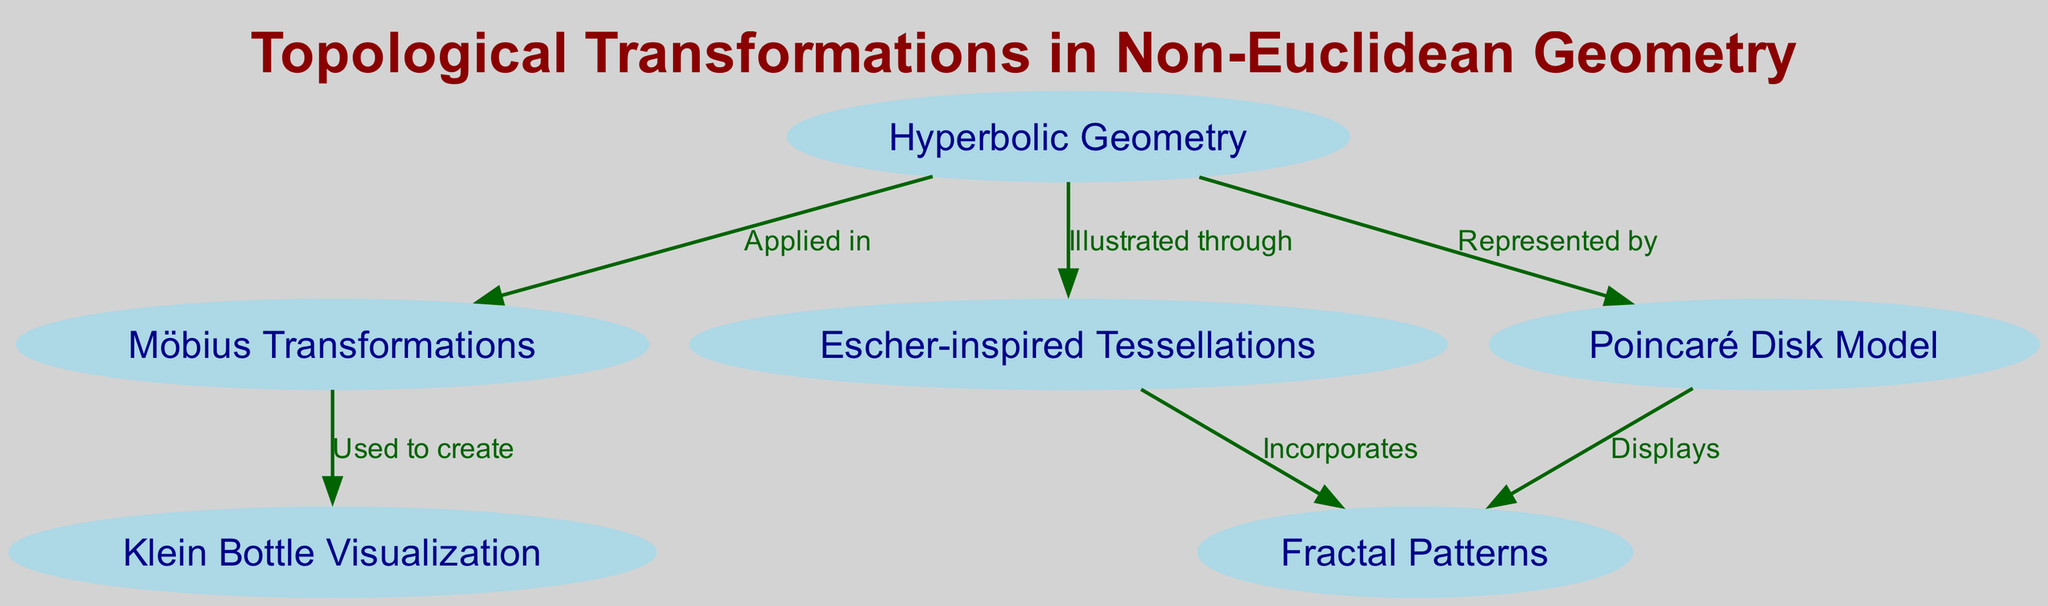What are three nodes related to Hyperbolic Geometry? Looking at the diagram, the edges stemming from "Hyperbolic Geometry" lead to three other nodes: "Möbius Transformations," "Escher-inspired Tessellations," and "Poincaré Disk Model." These represent the various concepts that are related to the main node.
Answer: Möbius Transformations, Escher-inspired Tessellations, Poincaré Disk Model How many nodes are in the diagram? The diagram illustrates a total of six distinct nodes: "Hyperbolic Geometry," "Möbius Transformations," "Escher-inspired Tessellations," "Poincaré Disk Model," "Klein Bottle Visualization," and "Fractal Patterns." Hence, counting all these nodes provides the answer.
Answer: 6 Which nodes are illustrated through Escher-inspired Tessellations? By following the directed edge that connects "Escher-inspired Tessellations," we see it leads to "Fractal Patterns." This indicates that "Fractal Patterns" is illustrated through "Escher-inspired Tessellations."
Answer: Fractal Patterns What is used to create the Klein Bottle Visualization? The edge connecting "Möbius Transformations" to "Klein Bottle Visualization" indicates that "Möbius Transformations" are used to create the "Klein Bottle Visualization."
Answer: Möbius Transformations Which node displays Fractal Patterns? Checking the edges, "Fractal Patterns" is displayed by two nodes in total: "Poincaré Disk Model" and "Escher-inspired Tessellations." After reviewing the edges, it's clear that both are responsible for displaying this concept.
Answer: Poincaré Disk Model, Escher-inspired Tessellations How many edges originate from Hyperbolic Geometry? Analyzing the edges that originate from varying nodes, we observe that "Hyperbolic Geometry" has three directed edges connecting it to "Möbius Transformations," "Escher-inspired Tessellations," and "Poincaré Disk Model." Counting these edges gives the answer.
Answer: 3 Which node is illustrated by Poincaré Disk Model? Since "Poincaré Disk Model" is an outgoing node, and the directed edge shows it connects to "Fractal Patterns," we confirm that "Fractal Patterns" is illustrated by this node.
Answer: Fractal Patterns 